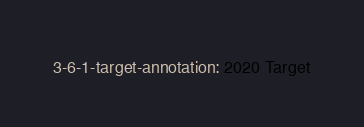Convert code to text. <code><loc_0><loc_0><loc_500><loc_500><_YAML_>3-6-1-target-annotation: 2020 Target</code> 